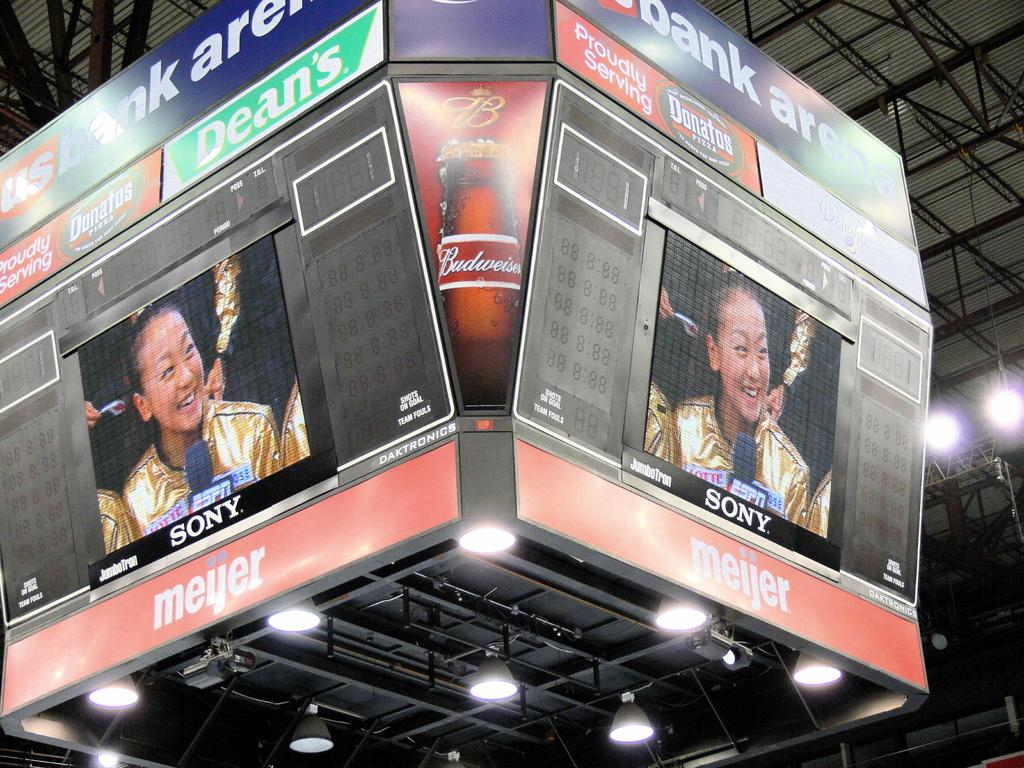What is the person in the image doing? The person is riding a skateboard. What can be seen in the background of the image? There is a sidewalk in the background. What story is the person on the skateboard telling in the image? There is no indication in the image that the person is telling a story. Can you see a plane flying in the sky in the image? There is no plane visible in the image. 